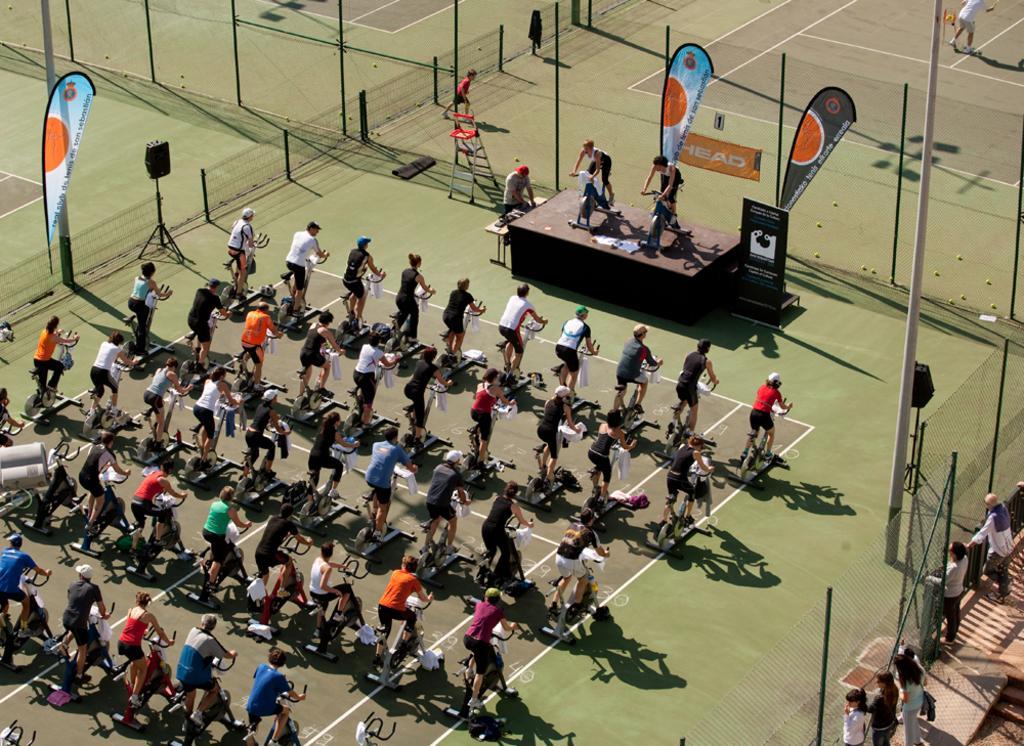Could you give a brief overview of what you see in this image? In this picture, we see many people are cycling. In front of them, we see a stage on which two people are cycling. Beside them, we see a table and a man is standing beside that. Beside him, we see the stand. Beside the stage, we see a board in black color with some text written on it. Behind him, we see the fence and banners in blue and black color with some text written on it. Behind that, we see the balls and the boy is playing with the balls. On the left side, we see the fence. In the right bottom, we see people are standing beside the fence. 